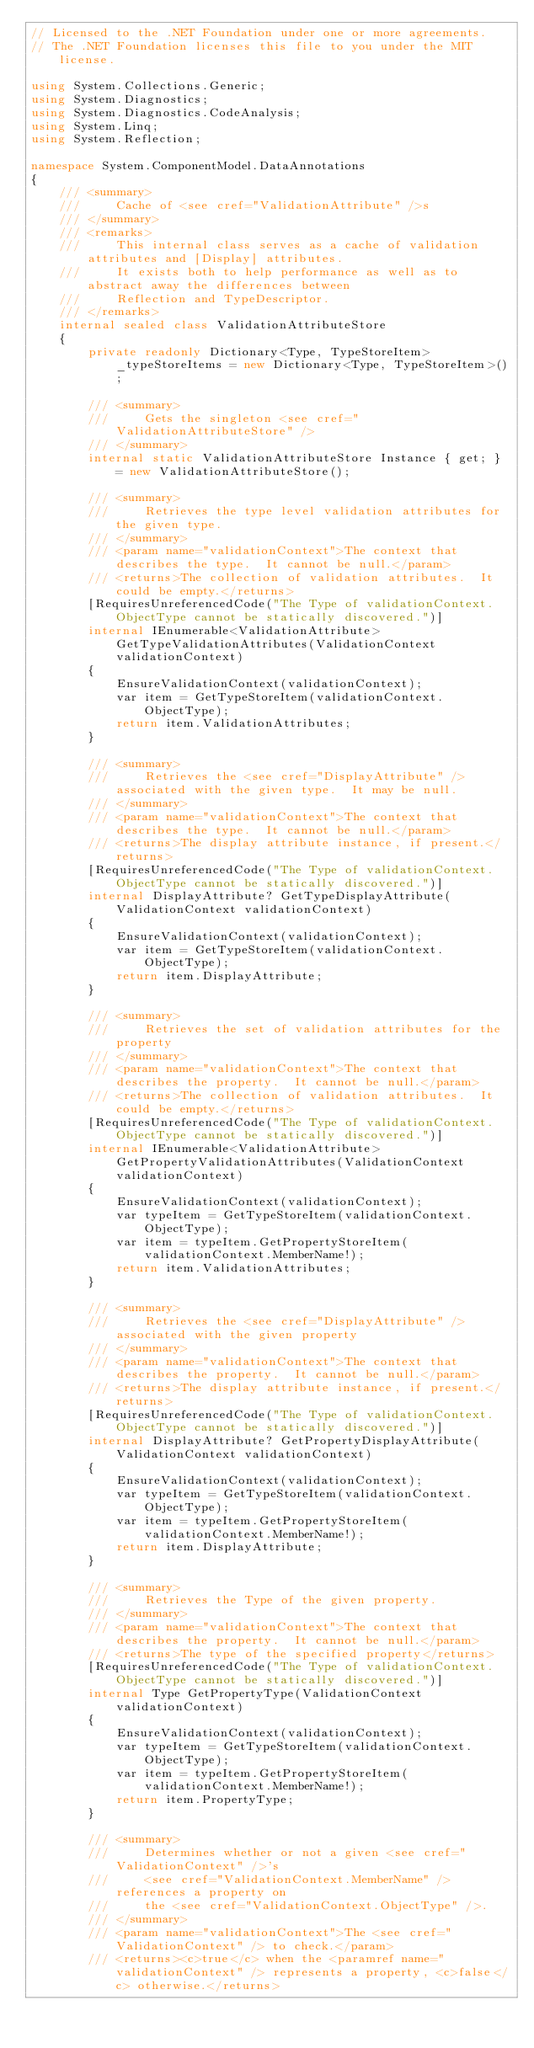Convert code to text. <code><loc_0><loc_0><loc_500><loc_500><_C#_>// Licensed to the .NET Foundation under one or more agreements.
// The .NET Foundation licenses this file to you under the MIT license.

using System.Collections.Generic;
using System.Diagnostics;
using System.Diagnostics.CodeAnalysis;
using System.Linq;
using System.Reflection;

namespace System.ComponentModel.DataAnnotations
{
    /// <summary>
    ///     Cache of <see cref="ValidationAttribute" />s
    /// </summary>
    /// <remarks>
    ///     This internal class serves as a cache of validation attributes and [Display] attributes.
    ///     It exists both to help performance as well as to abstract away the differences between
    ///     Reflection and TypeDescriptor.
    /// </remarks>
    internal sealed class ValidationAttributeStore
    {
        private readonly Dictionary<Type, TypeStoreItem> _typeStoreItems = new Dictionary<Type, TypeStoreItem>();

        /// <summary>
        ///     Gets the singleton <see cref="ValidationAttributeStore" />
        /// </summary>
        internal static ValidationAttributeStore Instance { get; } = new ValidationAttributeStore();

        /// <summary>
        ///     Retrieves the type level validation attributes for the given type.
        /// </summary>
        /// <param name="validationContext">The context that describes the type.  It cannot be null.</param>
        /// <returns>The collection of validation attributes.  It could be empty.</returns>
        [RequiresUnreferencedCode("The Type of validationContext.ObjectType cannot be statically discovered.")]
        internal IEnumerable<ValidationAttribute> GetTypeValidationAttributes(ValidationContext validationContext)
        {
            EnsureValidationContext(validationContext);
            var item = GetTypeStoreItem(validationContext.ObjectType);
            return item.ValidationAttributes;
        }

        /// <summary>
        ///     Retrieves the <see cref="DisplayAttribute" /> associated with the given type.  It may be null.
        /// </summary>
        /// <param name="validationContext">The context that describes the type.  It cannot be null.</param>
        /// <returns>The display attribute instance, if present.</returns>
        [RequiresUnreferencedCode("The Type of validationContext.ObjectType cannot be statically discovered.")]
        internal DisplayAttribute? GetTypeDisplayAttribute(ValidationContext validationContext)
        {
            EnsureValidationContext(validationContext);
            var item = GetTypeStoreItem(validationContext.ObjectType);
            return item.DisplayAttribute;
        }

        /// <summary>
        ///     Retrieves the set of validation attributes for the property
        /// </summary>
        /// <param name="validationContext">The context that describes the property.  It cannot be null.</param>
        /// <returns>The collection of validation attributes.  It could be empty.</returns>
        [RequiresUnreferencedCode("The Type of validationContext.ObjectType cannot be statically discovered.")]
        internal IEnumerable<ValidationAttribute> GetPropertyValidationAttributes(ValidationContext validationContext)
        {
            EnsureValidationContext(validationContext);
            var typeItem = GetTypeStoreItem(validationContext.ObjectType);
            var item = typeItem.GetPropertyStoreItem(validationContext.MemberName!);
            return item.ValidationAttributes;
        }

        /// <summary>
        ///     Retrieves the <see cref="DisplayAttribute" /> associated with the given property
        /// </summary>
        /// <param name="validationContext">The context that describes the property.  It cannot be null.</param>
        /// <returns>The display attribute instance, if present.</returns>
        [RequiresUnreferencedCode("The Type of validationContext.ObjectType cannot be statically discovered.")]
        internal DisplayAttribute? GetPropertyDisplayAttribute(ValidationContext validationContext)
        {
            EnsureValidationContext(validationContext);
            var typeItem = GetTypeStoreItem(validationContext.ObjectType);
            var item = typeItem.GetPropertyStoreItem(validationContext.MemberName!);
            return item.DisplayAttribute;
        }

        /// <summary>
        ///     Retrieves the Type of the given property.
        /// </summary>
        /// <param name="validationContext">The context that describes the property.  It cannot be null.</param>
        /// <returns>The type of the specified property</returns>
        [RequiresUnreferencedCode("The Type of validationContext.ObjectType cannot be statically discovered.")]
        internal Type GetPropertyType(ValidationContext validationContext)
        {
            EnsureValidationContext(validationContext);
            var typeItem = GetTypeStoreItem(validationContext.ObjectType);
            var item = typeItem.GetPropertyStoreItem(validationContext.MemberName!);
            return item.PropertyType;
        }

        /// <summary>
        ///     Determines whether or not a given <see cref="ValidationContext" />'s
        ///     <see cref="ValidationContext.MemberName" /> references a property on
        ///     the <see cref="ValidationContext.ObjectType" />.
        /// </summary>
        /// <param name="validationContext">The <see cref="ValidationContext" /> to check.</param>
        /// <returns><c>true</c> when the <paramref name="validationContext" /> represents a property, <c>false</c> otherwise.</returns></code> 